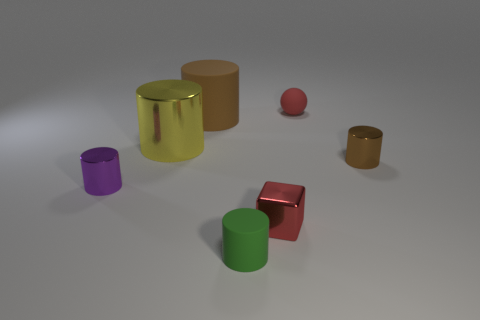There is a tiny cube that is the same color as the matte ball; what material is it?
Provide a short and direct response. Metal. Is there a tiny object that has the same color as the large rubber cylinder?
Provide a succinct answer. Yes. There is a tiny green cylinder on the right side of the large yellow thing; what is it made of?
Provide a short and direct response. Rubber. How many other green matte objects are the same shape as the green matte object?
Provide a succinct answer. 0. Does the tiny matte ball have the same color as the big metal thing?
Your answer should be very brief. No. There is a small red thing that is in front of the tiny matte thing behind the tiny red thing that is in front of the big brown matte object; what is its material?
Provide a short and direct response. Metal. There is a red ball; are there any red matte things on the right side of it?
Provide a succinct answer. No. The brown metal object that is the same size as the green cylinder is what shape?
Your response must be concise. Cylinder. Do the purple thing and the tiny brown thing have the same material?
Make the answer very short. Yes. What number of metallic things are either small green blocks or tiny purple cylinders?
Offer a terse response. 1. 